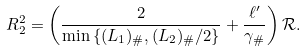<formula> <loc_0><loc_0><loc_500><loc_500>R _ { 2 } ^ { 2 } = \left ( \frac { 2 } { \min \left \{ ( L _ { 1 } ) _ { \# } , ( L _ { 2 } ) _ { \# } / 2 \right \} } + \frac { \ell ^ { \prime } } { \gamma _ { \# } } \right ) \mathcal { R } .</formula> 